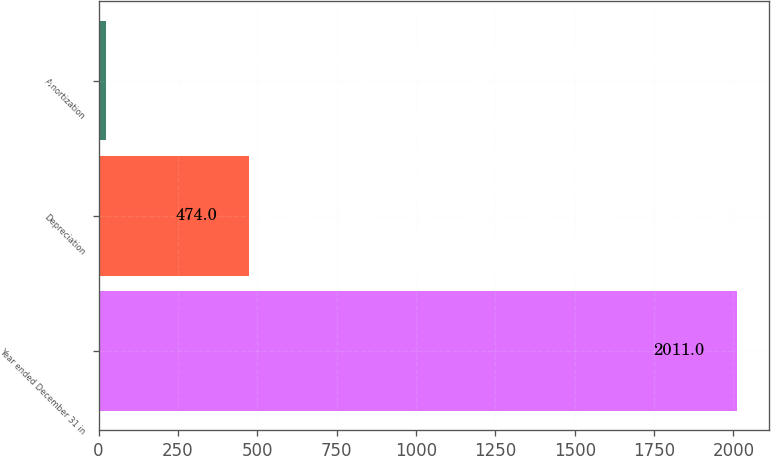<chart> <loc_0><loc_0><loc_500><loc_500><bar_chart><fcel>Year ended December 31 in<fcel>Depreciation<fcel>Amortization<nl><fcel>2011<fcel>474<fcel>22<nl></chart> 